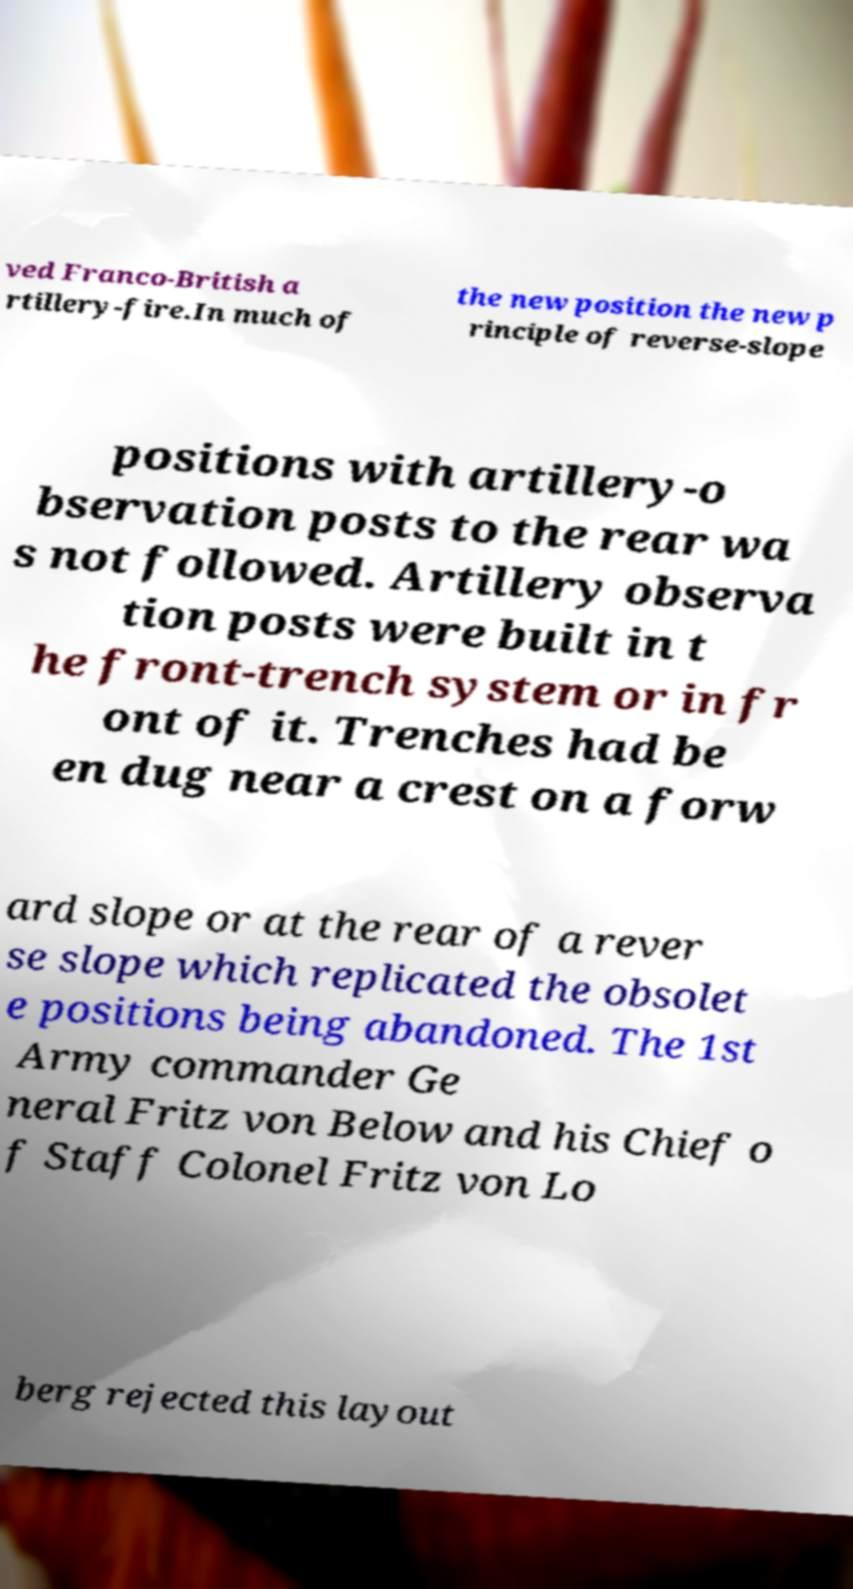Could you assist in decoding the text presented in this image and type it out clearly? ved Franco-British a rtillery-fire.In much of the new position the new p rinciple of reverse-slope positions with artillery-o bservation posts to the rear wa s not followed. Artillery observa tion posts were built in t he front-trench system or in fr ont of it. Trenches had be en dug near a crest on a forw ard slope or at the rear of a rever se slope which replicated the obsolet e positions being abandoned. The 1st Army commander Ge neral Fritz von Below and his Chief o f Staff Colonel Fritz von Lo berg rejected this layout 